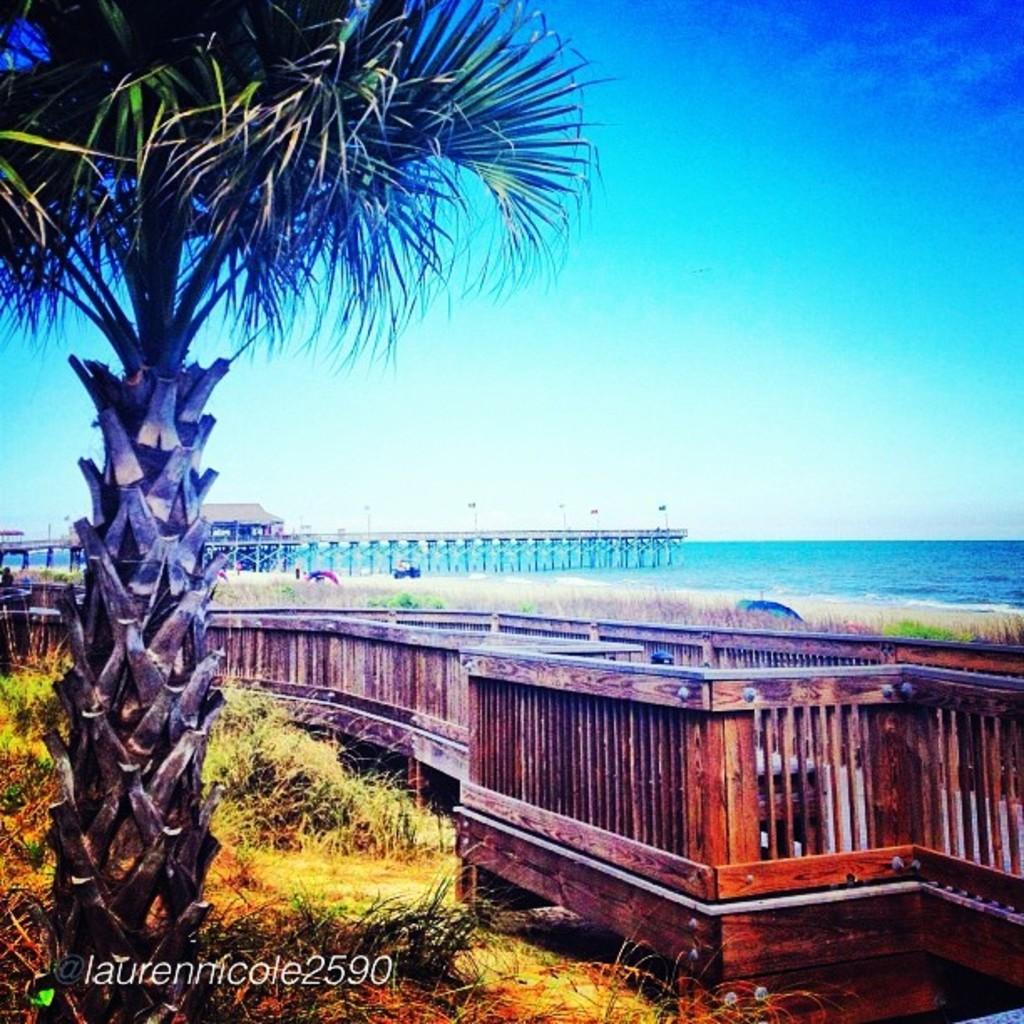Can you describe this image briefly? In this image I can see the tree, grass, bridge, shed, poles and wooden fencing and the water. The sky is in blue and white color. 